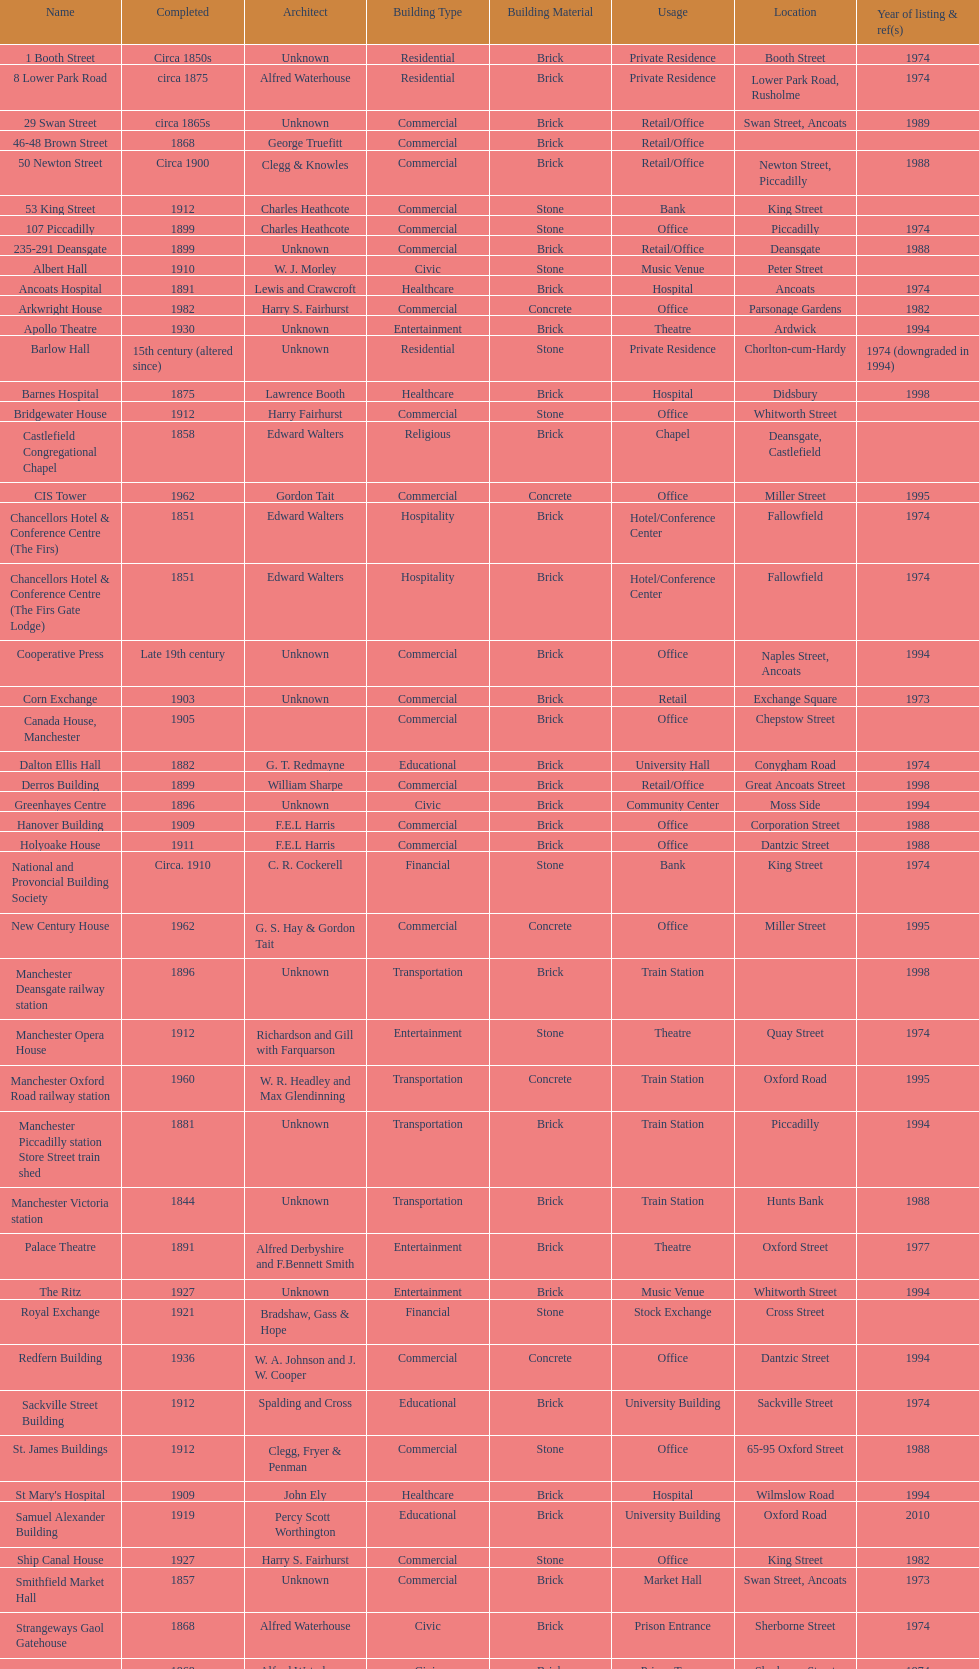What is the difference, in years, between the completion dates of 53 king street and castlefield congregational chapel? 54 years. 